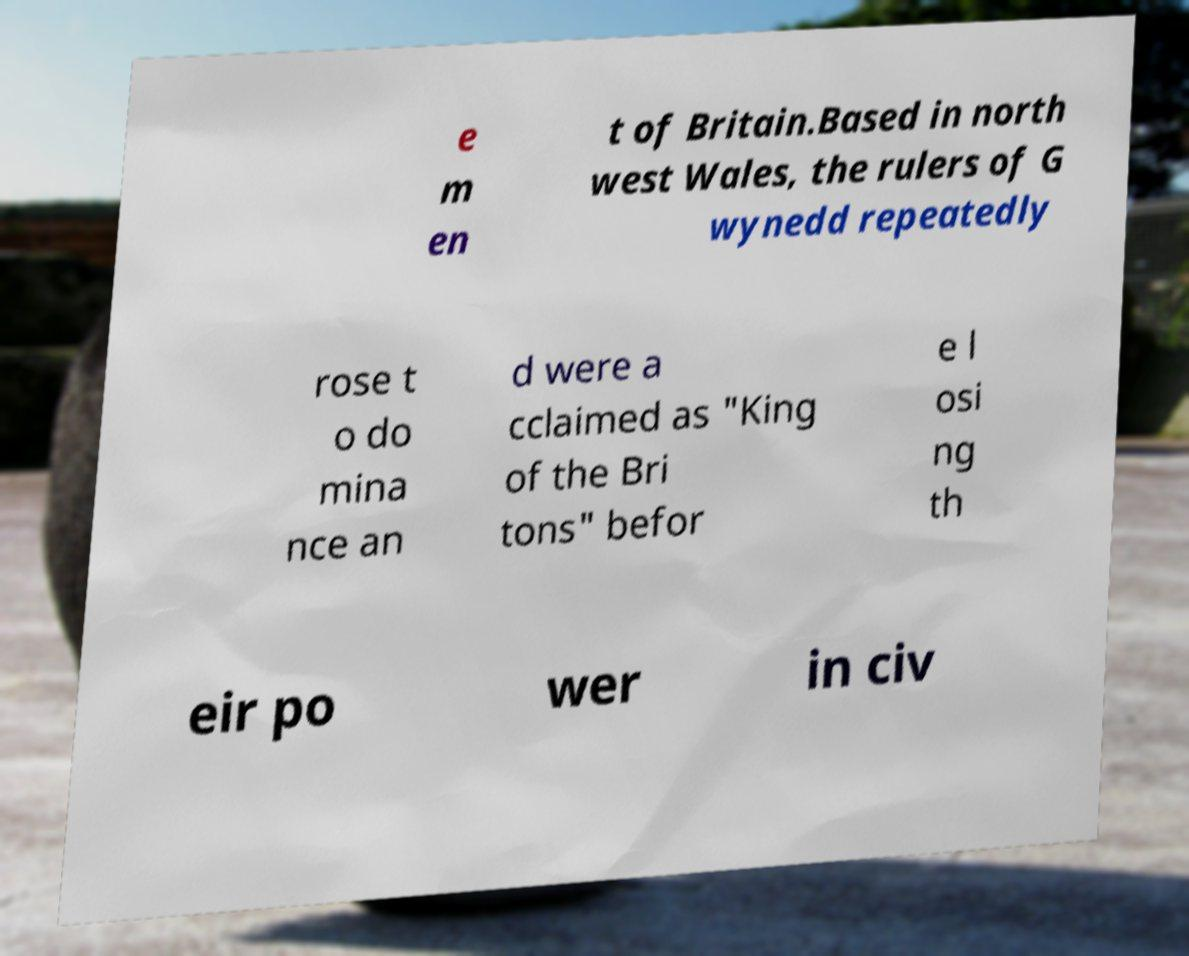Could you extract and type out the text from this image? e m en t of Britain.Based in north west Wales, the rulers of G wynedd repeatedly rose t o do mina nce an d were a cclaimed as "King of the Bri tons" befor e l osi ng th eir po wer in civ 